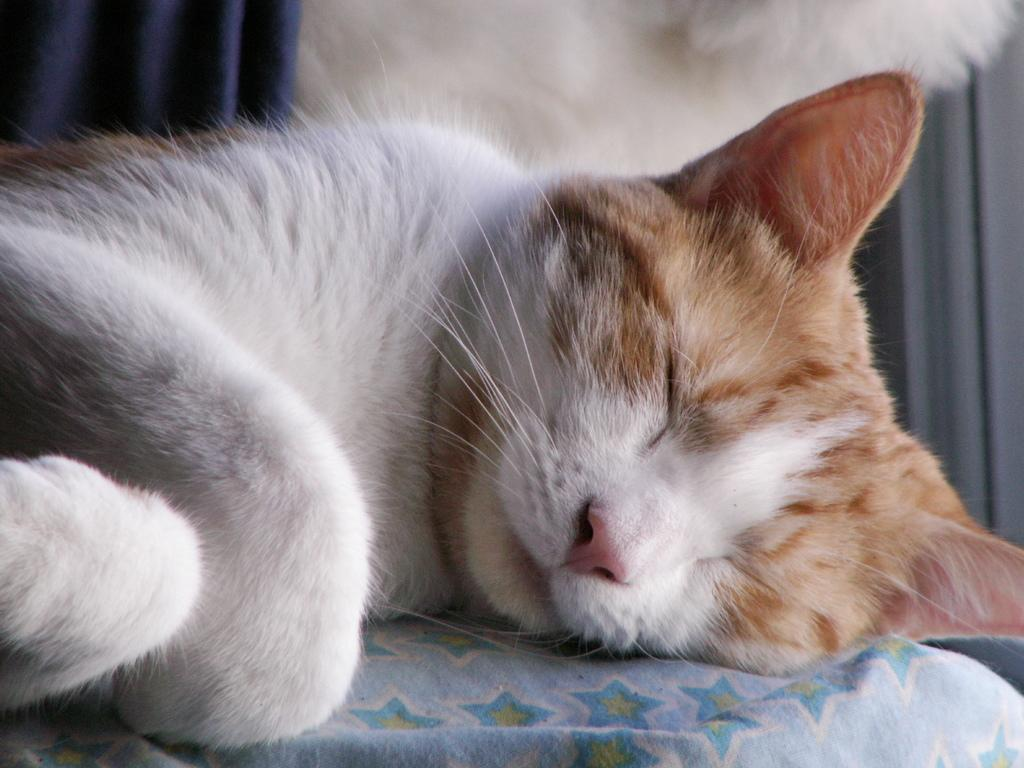What animal can be seen on a platform in the image? There is a cat on a platform in the image. What type of material is visible in the image? There is a cloth visible in the image. What color object can be seen in the background of the image? There is a white color object in the background of the image. What type of window treatment is present in the background of the image? There are curtains in the background of the image. What month is the protest taking place in the image? There is no protest present in the image, so it is not possible to determine the month. 